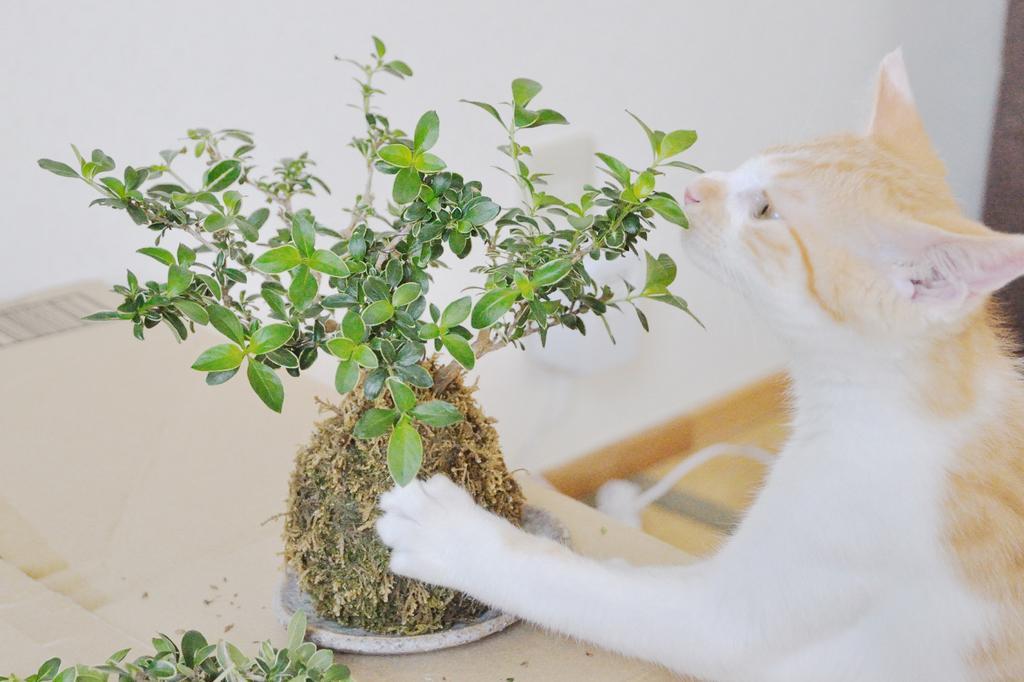In one or two sentences, can you explain what this image depicts? In this image there is a table on that table there is a plant and a cat is touching that plan. 